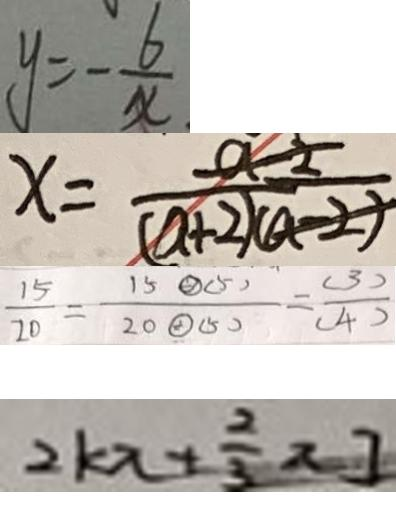<formula> <loc_0><loc_0><loc_500><loc_500>y = - \frac { 6 } { x } 
 x = ( a + 2 ) 
 \frac { 1 5 } { 2 0 } = \frac { 1 5 \textcircled { \div } ( 5 ) } { 2 0 \textcircled { \div } ( 5 ) } = \frac { ( 3 ) } { ( 4 ) } 
 2 k x + \frac { 2 } { 3 } x ]</formula> 